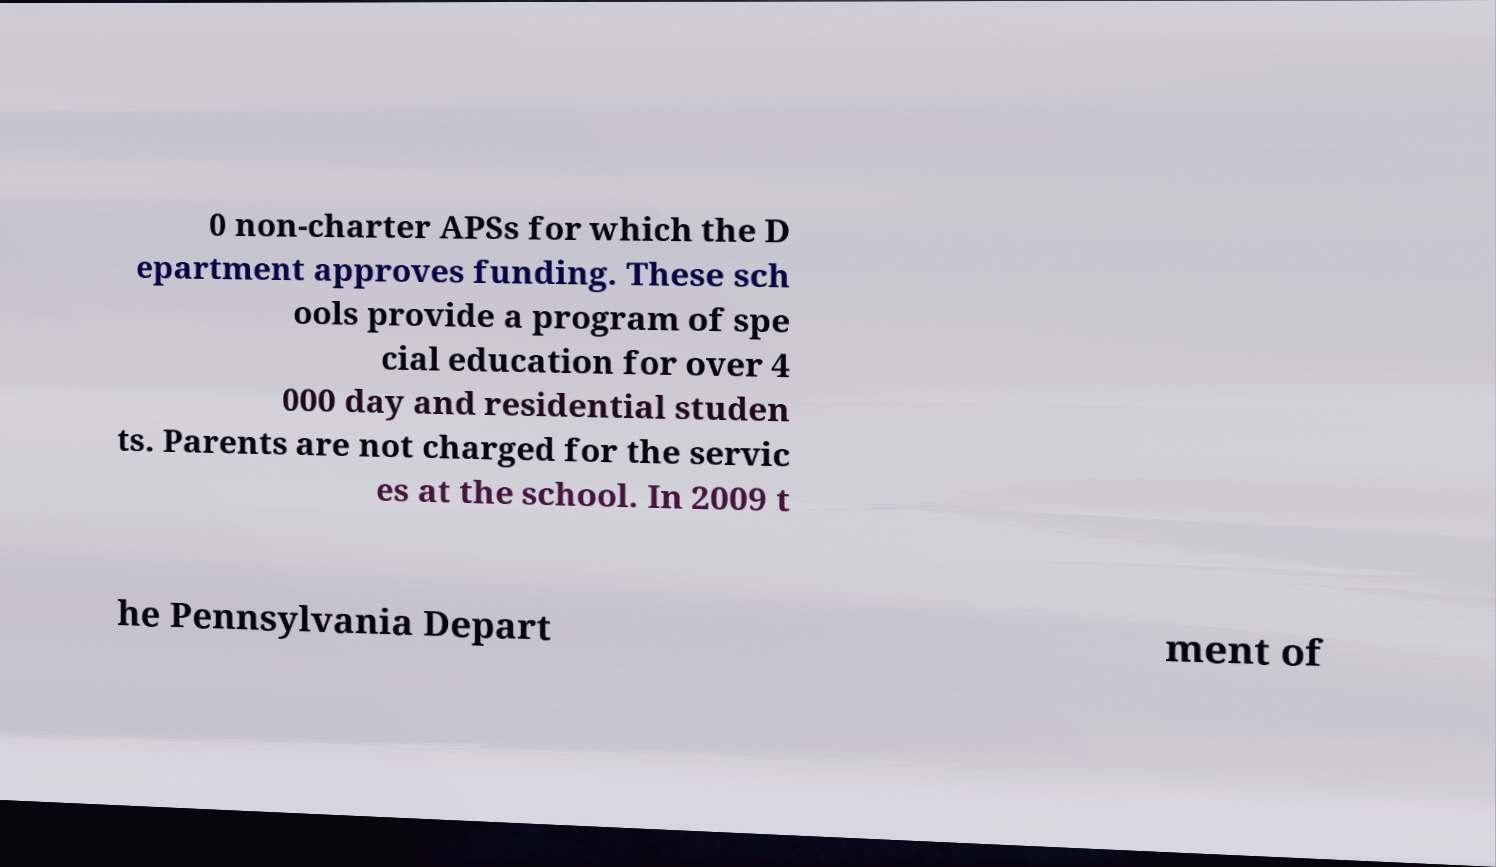There's text embedded in this image that I need extracted. Can you transcribe it verbatim? 0 non-charter APSs for which the D epartment approves funding. These sch ools provide a program of spe cial education for over 4 000 day and residential studen ts. Parents are not charged for the servic es at the school. In 2009 t he Pennsylvania Depart ment of 